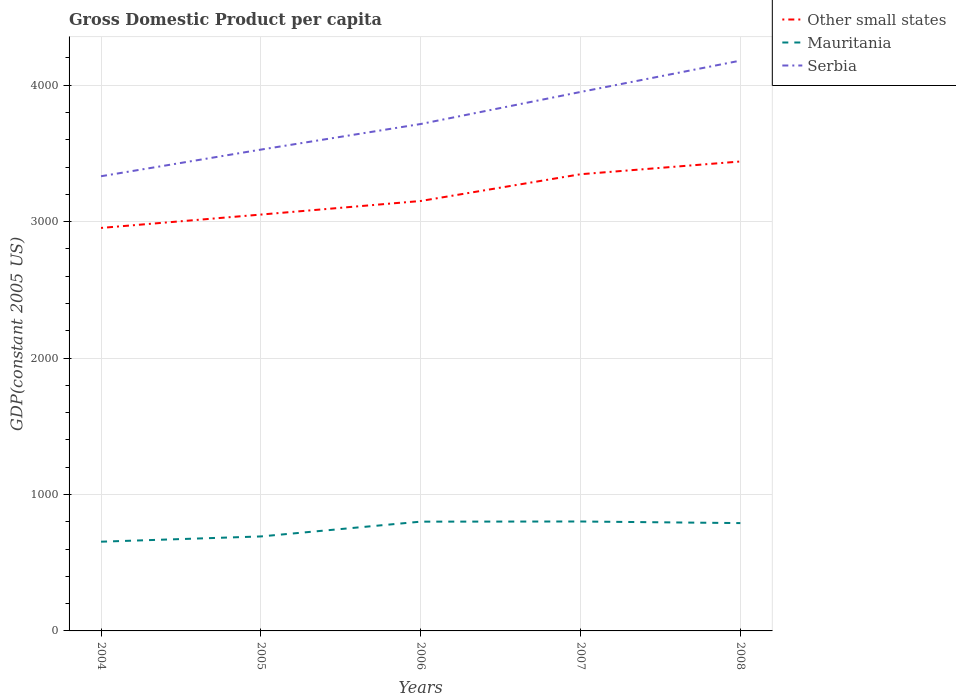Is the number of lines equal to the number of legend labels?
Give a very brief answer. Yes. Across all years, what is the maximum GDP per capita in Serbia?
Provide a short and direct response. 3332.89. What is the total GDP per capita in Mauritania in the graph?
Give a very brief answer. -38.51. What is the difference between the highest and the second highest GDP per capita in Serbia?
Provide a short and direct response. 847.42. What is the difference between the highest and the lowest GDP per capita in Other small states?
Your response must be concise. 2. Does the graph contain any zero values?
Make the answer very short. No. Does the graph contain grids?
Make the answer very short. Yes. What is the title of the graph?
Your response must be concise. Gross Domestic Product per capita. Does "Egypt, Arab Rep." appear as one of the legend labels in the graph?
Your response must be concise. No. What is the label or title of the Y-axis?
Make the answer very short. GDP(constant 2005 US). What is the GDP(constant 2005 US) of Other small states in 2004?
Your response must be concise. 2953.97. What is the GDP(constant 2005 US) in Mauritania in 2004?
Keep it short and to the point. 654.07. What is the GDP(constant 2005 US) of Serbia in 2004?
Offer a very short reply. 3332.89. What is the GDP(constant 2005 US) in Other small states in 2005?
Provide a short and direct response. 3051.89. What is the GDP(constant 2005 US) in Mauritania in 2005?
Offer a terse response. 692.58. What is the GDP(constant 2005 US) in Serbia in 2005?
Provide a succinct answer. 3528.13. What is the GDP(constant 2005 US) of Other small states in 2006?
Give a very brief answer. 3151.44. What is the GDP(constant 2005 US) in Mauritania in 2006?
Your answer should be compact. 800.99. What is the GDP(constant 2005 US) in Serbia in 2006?
Your answer should be compact. 3715.74. What is the GDP(constant 2005 US) in Other small states in 2007?
Provide a short and direct response. 3347.53. What is the GDP(constant 2005 US) in Mauritania in 2007?
Give a very brief answer. 802.15. What is the GDP(constant 2005 US) in Serbia in 2007?
Give a very brief answer. 3950.54. What is the GDP(constant 2005 US) of Other small states in 2008?
Provide a short and direct response. 3440.97. What is the GDP(constant 2005 US) of Mauritania in 2008?
Keep it short and to the point. 790.33. What is the GDP(constant 2005 US) in Serbia in 2008?
Provide a succinct answer. 4180.31. Across all years, what is the maximum GDP(constant 2005 US) in Other small states?
Your answer should be very brief. 3440.97. Across all years, what is the maximum GDP(constant 2005 US) of Mauritania?
Your answer should be very brief. 802.15. Across all years, what is the maximum GDP(constant 2005 US) of Serbia?
Your answer should be compact. 4180.31. Across all years, what is the minimum GDP(constant 2005 US) in Other small states?
Your answer should be very brief. 2953.97. Across all years, what is the minimum GDP(constant 2005 US) in Mauritania?
Make the answer very short. 654.07. Across all years, what is the minimum GDP(constant 2005 US) in Serbia?
Provide a short and direct response. 3332.89. What is the total GDP(constant 2005 US) of Other small states in the graph?
Your response must be concise. 1.59e+04. What is the total GDP(constant 2005 US) in Mauritania in the graph?
Your answer should be very brief. 3740.12. What is the total GDP(constant 2005 US) in Serbia in the graph?
Your response must be concise. 1.87e+04. What is the difference between the GDP(constant 2005 US) of Other small states in 2004 and that in 2005?
Provide a short and direct response. -97.92. What is the difference between the GDP(constant 2005 US) in Mauritania in 2004 and that in 2005?
Make the answer very short. -38.51. What is the difference between the GDP(constant 2005 US) of Serbia in 2004 and that in 2005?
Make the answer very short. -195.24. What is the difference between the GDP(constant 2005 US) of Other small states in 2004 and that in 2006?
Provide a short and direct response. -197.48. What is the difference between the GDP(constant 2005 US) in Mauritania in 2004 and that in 2006?
Offer a terse response. -146.93. What is the difference between the GDP(constant 2005 US) of Serbia in 2004 and that in 2006?
Offer a terse response. -382.85. What is the difference between the GDP(constant 2005 US) in Other small states in 2004 and that in 2007?
Give a very brief answer. -393.56. What is the difference between the GDP(constant 2005 US) of Mauritania in 2004 and that in 2007?
Make the answer very short. -148.09. What is the difference between the GDP(constant 2005 US) of Serbia in 2004 and that in 2007?
Ensure brevity in your answer.  -617.65. What is the difference between the GDP(constant 2005 US) of Other small states in 2004 and that in 2008?
Offer a terse response. -487.01. What is the difference between the GDP(constant 2005 US) of Mauritania in 2004 and that in 2008?
Your answer should be compact. -136.26. What is the difference between the GDP(constant 2005 US) of Serbia in 2004 and that in 2008?
Make the answer very short. -847.42. What is the difference between the GDP(constant 2005 US) in Other small states in 2005 and that in 2006?
Provide a succinct answer. -99.55. What is the difference between the GDP(constant 2005 US) in Mauritania in 2005 and that in 2006?
Provide a short and direct response. -108.42. What is the difference between the GDP(constant 2005 US) in Serbia in 2005 and that in 2006?
Your answer should be compact. -187.61. What is the difference between the GDP(constant 2005 US) in Other small states in 2005 and that in 2007?
Your answer should be very brief. -295.64. What is the difference between the GDP(constant 2005 US) of Mauritania in 2005 and that in 2007?
Make the answer very short. -109.58. What is the difference between the GDP(constant 2005 US) of Serbia in 2005 and that in 2007?
Your response must be concise. -422.41. What is the difference between the GDP(constant 2005 US) of Other small states in 2005 and that in 2008?
Give a very brief answer. -389.09. What is the difference between the GDP(constant 2005 US) of Mauritania in 2005 and that in 2008?
Provide a short and direct response. -97.76. What is the difference between the GDP(constant 2005 US) of Serbia in 2005 and that in 2008?
Ensure brevity in your answer.  -652.18. What is the difference between the GDP(constant 2005 US) in Other small states in 2006 and that in 2007?
Provide a succinct answer. -196.09. What is the difference between the GDP(constant 2005 US) in Mauritania in 2006 and that in 2007?
Your answer should be compact. -1.16. What is the difference between the GDP(constant 2005 US) in Serbia in 2006 and that in 2007?
Make the answer very short. -234.8. What is the difference between the GDP(constant 2005 US) in Other small states in 2006 and that in 2008?
Give a very brief answer. -289.53. What is the difference between the GDP(constant 2005 US) of Mauritania in 2006 and that in 2008?
Make the answer very short. 10.66. What is the difference between the GDP(constant 2005 US) in Serbia in 2006 and that in 2008?
Your answer should be very brief. -464.57. What is the difference between the GDP(constant 2005 US) of Other small states in 2007 and that in 2008?
Keep it short and to the point. -93.45. What is the difference between the GDP(constant 2005 US) of Mauritania in 2007 and that in 2008?
Offer a very short reply. 11.82. What is the difference between the GDP(constant 2005 US) in Serbia in 2007 and that in 2008?
Your response must be concise. -229.77. What is the difference between the GDP(constant 2005 US) in Other small states in 2004 and the GDP(constant 2005 US) in Mauritania in 2005?
Keep it short and to the point. 2261.39. What is the difference between the GDP(constant 2005 US) in Other small states in 2004 and the GDP(constant 2005 US) in Serbia in 2005?
Your answer should be compact. -574.16. What is the difference between the GDP(constant 2005 US) in Mauritania in 2004 and the GDP(constant 2005 US) in Serbia in 2005?
Provide a succinct answer. -2874.06. What is the difference between the GDP(constant 2005 US) of Other small states in 2004 and the GDP(constant 2005 US) of Mauritania in 2006?
Ensure brevity in your answer.  2152.97. What is the difference between the GDP(constant 2005 US) in Other small states in 2004 and the GDP(constant 2005 US) in Serbia in 2006?
Ensure brevity in your answer.  -761.78. What is the difference between the GDP(constant 2005 US) in Mauritania in 2004 and the GDP(constant 2005 US) in Serbia in 2006?
Provide a short and direct response. -3061.68. What is the difference between the GDP(constant 2005 US) in Other small states in 2004 and the GDP(constant 2005 US) in Mauritania in 2007?
Ensure brevity in your answer.  2151.81. What is the difference between the GDP(constant 2005 US) in Other small states in 2004 and the GDP(constant 2005 US) in Serbia in 2007?
Your answer should be compact. -996.57. What is the difference between the GDP(constant 2005 US) in Mauritania in 2004 and the GDP(constant 2005 US) in Serbia in 2007?
Provide a short and direct response. -3296.47. What is the difference between the GDP(constant 2005 US) of Other small states in 2004 and the GDP(constant 2005 US) of Mauritania in 2008?
Give a very brief answer. 2163.63. What is the difference between the GDP(constant 2005 US) of Other small states in 2004 and the GDP(constant 2005 US) of Serbia in 2008?
Offer a very short reply. -1226.35. What is the difference between the GDP(constant 2005 US) of Mauritania in 2004 and the GDP(constant 2005 US) of Serbia in 2008?
Offer a very short reply. -3526.24. What is the difference between the GDP(constant 2005 US) of Other small states in 2005 and the GDP(constant 2005 US) of Mauritania in 2006?
Ensure brevity in your answer.  2250.9. What is the difference between the GDP(constant 2005 US) in Other small states in 2005 and the GDP(constant 2005 US) in Serbia in 2006?
Your response must be concise. -663.85. What is the difference between the GDP(constant 2005 US) of Mauritania in 2005 and the GDP(constant 2005 US) of Serbia in 2006?
Make the answer very short. -3023.17. What is the difference between the GDP(constant 2005 US) in Other small states in 2005 and the GDP(constant 2005 US) in Mauritania in 2007?
Make the answer very short. 2249.74. What is the difference between the GDP(constant 2005 US) in Other small states in 2005 and the GDP(constant 2005 US) in Serbia in 2007?
Provide a short and direct response. -898.65. What is the difference between the GDP(constant 2005 US) in Mauritania in 2005 and the GDP(constant 2005 US) in Serbia in 2007?
Ensure brevity in your answer.  -3257.97. What is the difference between the GDP(constant 2005 US) of Other small states in 2005 and the GDP(constant 2005 US) of Mauritania in 2008?
Your answer should be very brief. 2261.56. What is the difference between the GDP(constant 2005 US) in Other small states in 2005 and the GDP(constant 2005 US) in Serbia in 2008?
Give a very brief answer. -1128.42. What is the difference between the GDP(constant 2005 US) in Mauritania in 2005 and the GDP(constant 2005 US) in Serbia in 2008?
Your answer should be compact. -3487.74. What is the difference between the GDP(constant 2005 US) in Other small states in 2006 and the GDP(constant 2005 US) in Mauritania in 2007?
Provide a succinct answer. 2349.29. What is the difference between the GDP(constant 2005 US) of Other small states in 2006 and the GDP(constant 2005 US) of Serbia in 2007?
Offer a terse response. -799.1. What is the difference between the GDP(constant 2005 US) in Mauritania in 2006 and the GDP(constant 2005 US) in Serbia in 2007?
Ensure brevity in your answer.  -3149.55. What is the difference between the GDP(constant 2005 US) of Other small states in 2006 and the GDP(constant 2005 US) of Mauritania in 2008?
Provide a succinct answer. 2361.11. What is the difference between the GDP(constant 2005 US) of Other small states in 2006 and the GDP(constant 2005 US) of Serbia in 2008?
Keep it short and to the point. -1028.87. What is the difference between the GDP(constant 2005 US) of Mauritania in 2006 and the GDP(constant 2005 US) of Serbia in 2008?
Make the answer very short. -3379.32. What is the difference between the GDP(constant 2005 US) in Other small states in 2007 and the GDP(constant 2005 US) in Mauritania in 2008?
Your answer should be very brief. 2557.2. What is the difference between the GDP(constant 2005 US) in Other small states in 2007 and the GDP(constant 2005 US) in Serbia in 2008?
Your answer should be very brief. -832.78. What is the difference between the GDP(constant 2005 US) of Mauritania in 2007 and the GDP(constant 2005 US) of Serbia in 2008?
Your answer should be very brief. -3378.16. What is the average GDP(constant 2005 US) in Other small states per year?
Provide a short and direct response. 3189.16. What is the average GDP(constant 2005 US) in Mauritania per year?
Offer a very short reply. 748.02. What is the average GDP(constant 2005 US) of Serbia per year?
Keep it short and to the point. 3741.52. In the year 2004, what is the difference between the GDP(constant 2005 US) in Other small states and GDP(constant 2005 US) in Mauritania?
Offer a very short reply. 2299.9. In the year 2004, what is the difference between the GDP(constant 2005 US) of Other small states and GDP(constant 2005 US) of Serbia?
Make the answer very short. -378.92. In the year 2004, what is the difference between the GDP(constant 2005 US) in Mauritania and GDP(constant 2005 US) in Serbia?
Give a very brief answer. -2678.82. In the year 2005, what is the difference between the GDP(constant 2005 US) of Other small states and GDP(constant 2005 US) of Mauritania?
Ensure brevity in your answer.  2359.31. In the year 2005, what is the difference between the GDP(constant 2005 US) of Other small states and GDP(constant 2005 US) of Serbia?
Make the answer very short. -476.24. In the year 2005, what is the difference between the GDP(constant 2005 US) in Mauritania and GDP(constant 2005 US) in Serbia?
Your answer should be compact. -2835.55. In the year 2006, what is the difference between the GDP(constant 2005 US) in Other small states and GDP(constant 2005 US) in Mauritania?
Offer a terse response. 2350.45. In the year 2006, what is the difference between the GDP(constant 2005 US) of Other small states and GDP(constant 2005 US) of Serbia?
Make the answer very short. -564.3. In the year 2006, what is the difference between the GDP(constant 2005 US) of Mauritania and GDP(constant 2005 US) of Serbia?
Keep it short and to the point. -2914.75. In the year 2007, what is the difference between the GDP(constant 2005 US) in Other small states and GDP(constant 2005 US) in Mauritania?
Ensure brevity in your answer.  2545.38. In the year 2007, what is the difference between the GDP(constant 2005 US) of Other small states and GDP(constant 2005 US) of Serbia?
Keep it short and to the point. -603.01. In the year 2007, what is the difference between the GDP(constant 2005 US) of Mauritania and GDP(constant 2005 US) of Serbia?
Offer a terse response. -3148.39. In the year 2008, what is the difference between the GDP(constant 2005 US) in Other small states and GDP(constant 2005 US) in Mauritania?
Give a very brief answer. 2650.64. In the year 2008, what is the difference between the GDP(constant 2005 US) of Other small states and GDP(constant 2005 US) of Serbia?
Offer a terse response. -739.34. In the year 2008, what is the difference between the GDP(constant 2005 US) of Mauritania and GDP(constant 2005 US) of Serbia?
Give a very brief answer. -3389.98. What is the ratio of the GDP(constant 2005 US) in Other small states in 2004 to that in 2005?
Offer a very short reply. 0.97. What is the ratio of the GDP(constant 2005 US) in Mauritania in 2004 to that in 2005?
Give a very brief answer. 0.94. What is the ratio of the GDP(constant 2005 US) in Serbia in 2004 to that in 2005?
Your answer should be very brief. 0.94. What is the ratio of the GDP(constant 2005 US) of Other small states in 2004 to that in 2006?
Provide a succinct answer. 0.94. What is the ratio of the GDP(constant 2005 US) in Mauritania in 2004 to that in 2006?
Your response must be concise. 0.82. What is the ratio of the GDP(constant 2005 US) of Serbia in 2004 to that in 2006?
Keep it short and to the point. 0.9. What is the ratio of the GDP(constant 2005 US) in Other small states in 2004 to that in 2007?
Ensure brevity in your answer.  0.88. What is the ratio of the GDP(constant 2005 US) of Mauritania in 2004 to that in 2007?
Your answer should be very brief. 0.82. What is the ratio of the GDP(constant 2005 US) of Serbia in 2004 to that in 2007?
Provide a short and direct response. 0.84. What is the ratio of the GDP(constant 2005 US) in Other small states in 2004 to that in 2008?
Offer a very short reply. 0.86. What is the ratio of the GDP(constant 2005 US) of Mauritania in 2004 to that in 2008?
Offer a terse response. 0.83. What is the ratio of the GDP(constant 2005 US) of Serbia in 2004 to that in 2008?
Your answer should be very brief. 0.8. What is the ratio of the GDP(constant 2005 US) of Other small states in 2005 to that in 2006?
Your answer should be compact. 0.97. What is the ratio of the GDP(constant 2005 US) of Mauritania in 2005 to that in 2006?
Keep it short and to the point. 0.86. What is the ratio of the GDP(constant 2005 US) in Serbia in 2005 to that in 2006?
Give a very brief answer. 0.95. What is the ratio of the GDP(constant 2005 US) of Other small states in 2005 to that in 2007?
Make the answer very short. 0.91. What is the ratio of the GDP(constant 2005 US) of Mauritania in 2005 to that in 2007?
Your answer should be very brief. 0.86. What is the ratio of the GDP(constant 2005 US) in Serbia in 2005 to that in 2007?
Keep it short and to the point. 0.89. What is the ratio of the GDP(constant 2005 US) in Other small states in 2005 to that in 2008?
Keep it short and to the point. 0.89. What is the ratio of the GDP(constant 2005 US) in Mauritania in 2005 to that in 2008?
Provide a succinct answer. 0.88. What is the ratio of the GDP(constant 2005 US) in Serbia in 2005 to that in 2008?
Offer a very short reply. 0.84. What is the ratio of the GDP(constant 2005 US) in Other small states in 2006 to that in 2007?
Your response must be concise. 0.94. What is the ratio of the GDP(constant 2005 US) in Serbia in 2006 to that in 2007?
Offer a terse response. 0.94. What is the ratio of the GDP(constant 2005 US) in Other small states in 2006 to that in 2008?
Give a very brief answer. 0.92. What is the ratio of the GDP(constant 2005 US) of Mauritania in 2006 to that in 2008?
Offer a very short reply. 1.01. What is the ratio of the GDP(constant 2005 US) of Other small states in 2007 to that in 2008?
Your answer should be compact. 0.97. What is the ratio of the GDP(constant 2005 US) of Serbia in 2007 to that in 2008?
Your answer should be very brief. 0.94. What is the difference between the highest and the second highest GDP(constant 2005 US) in Other small states?
Offer a very short reply. 93.45. What is the difference between the highest and the second highest GDP(constant 2005 US) of Mauritania?
Ensure brevity in your answer.  1.16. What is the difference between the highest and the second highest GDP(constant 2005 US) of Serbia?
Provide a succinct answer. 229.77. What is the difference between the highest and the lowest GDP(constant 2005 US) in Other small states?
Provide a short and direct response. 487.01. What is the difference between the highest and the lowest GDP(constant 2005 US) in Mauritania?
Offer a terse response. 148.09. What is the difference between the highest and the lowest GDP(constant 2005 US) in Serbia?
Offer a terse response. 847.42. 